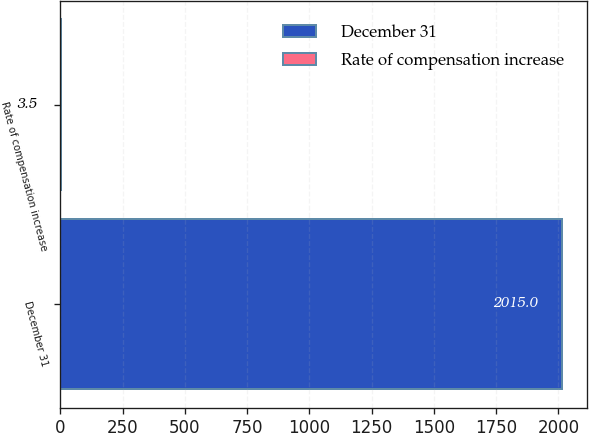Convert chart. <chart><loc_0><loc_0><loc_500><loc_500><bar_chart><fcel>December 31<fcel>Rate of compensation increase<nl><fcel>2015<fcel>3.5<nl></chart> 